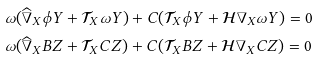<formula> <loc_0><loc_0><loc_500><loc_500>& \omega ( \widehat { \nabla } _ { X } \phi Y + \mathcal { T } _ { X } \omega Y ) + C ( \mathcal { T } _ { X } \phi Y + \mathcal { H } \nabla _ { X } \omega Y ) = 0 \\ & \omega ( \widehat { \nabla } _ { X } B Z + \mathcal { T } _ { X } C Z ) + C ( \mathcal { T } _ { X } B Z + \mathcal { H } \nabla _ { X } C Z ) = 0</formula> 